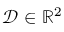<formula> <loc_0><loc_0><loc_500><loc_500>\mathcal { D } \in \mathbb { R } ^ { 2 }</formula> 